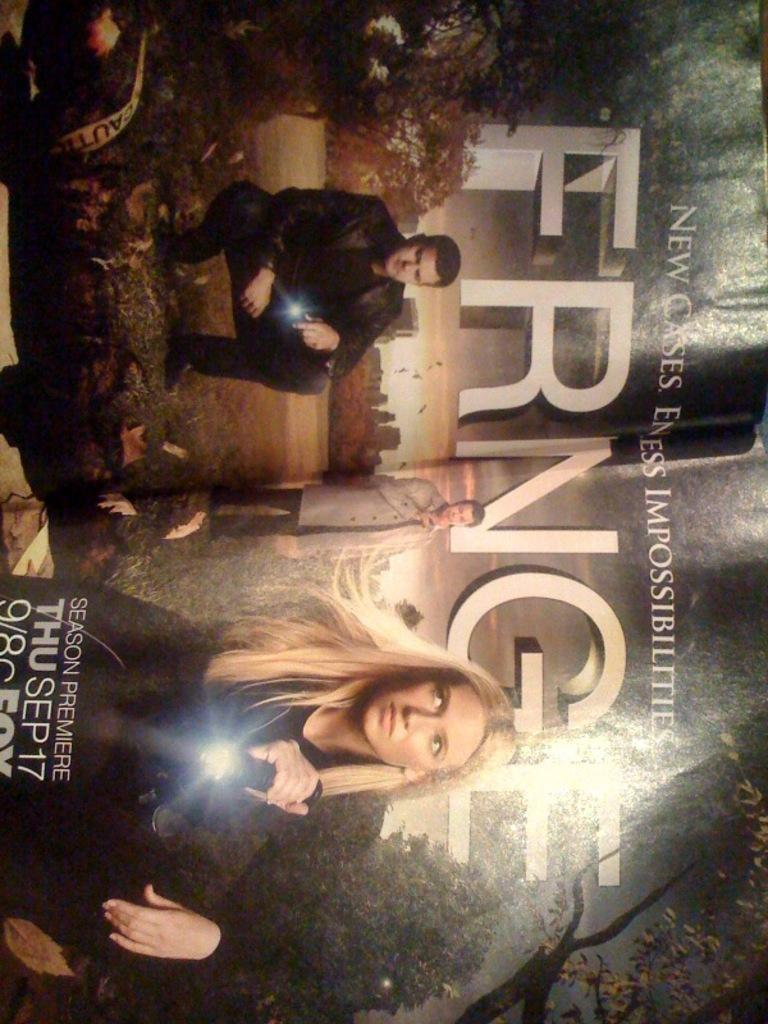Provide a one-sentence caption for the provided image. Television show poster for The Fringe that premiees September 17th. 